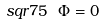<formula> <loc_0><loc_0><loc_500><loc_500>\ s q r 7 5 \ \Phi = 0</formula> 